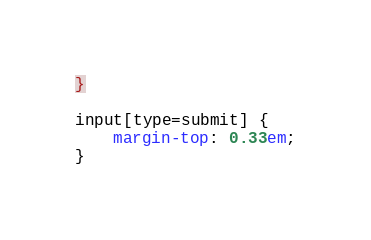<code> <loc_0><loc_0><loc_500><loc_500><_CSS_>}

input[type=submit] {
    margin-top: 0.33em;
}
</code> 